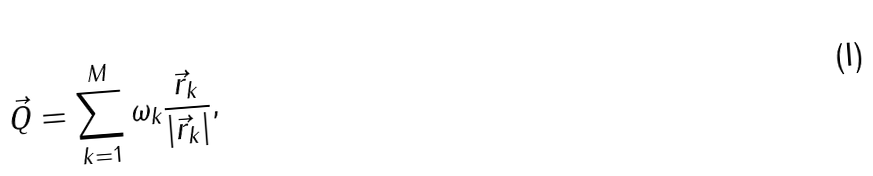Convert formula to latex. <formula><loc_0><loc_0><loc_500><loc_500>\vec { Q } = \sum ^ { M } _ { k = 1 } \omega _ { k } \frac { \vec { r } _ { k } } { | \vec { r } _ { k } | } ,</formula> 